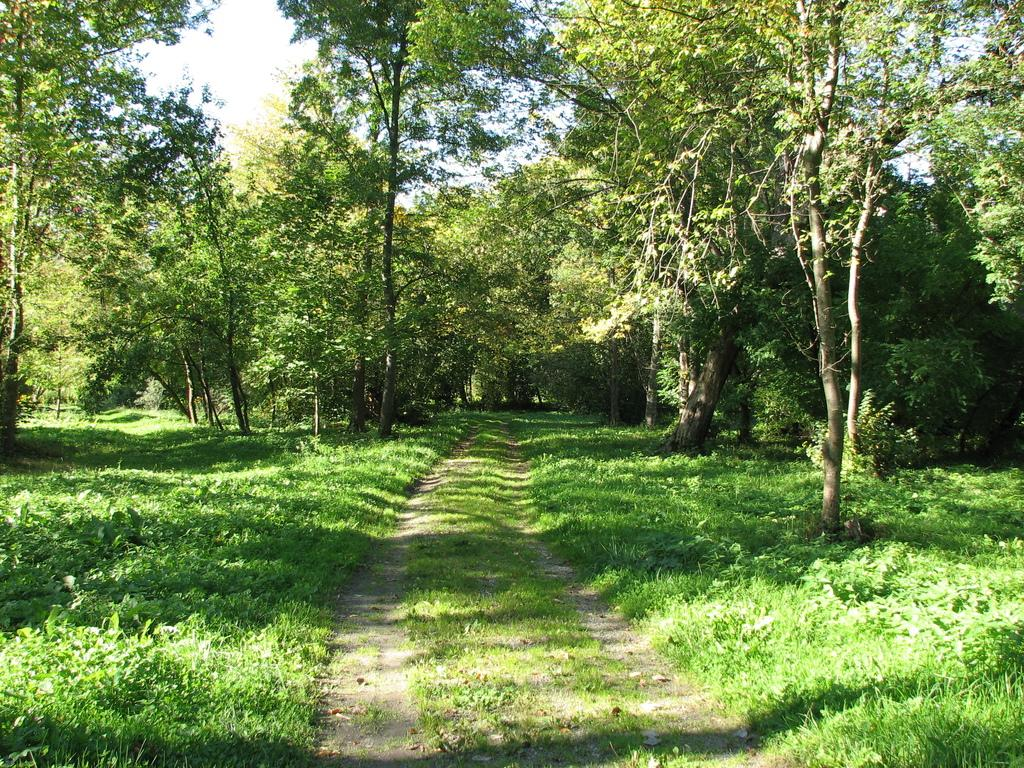What type of vegetation can be seen in the image? There is grass, trees, and plants in the image. What part of the natural environment is visible in the image? The sky is visible in the image. Can you describe the vegetation in the image? The image contains grass, trees, and various plants. What is the interest rate for the loan mentioned in the image? There is no mention of a loan or interest rate in the image. 